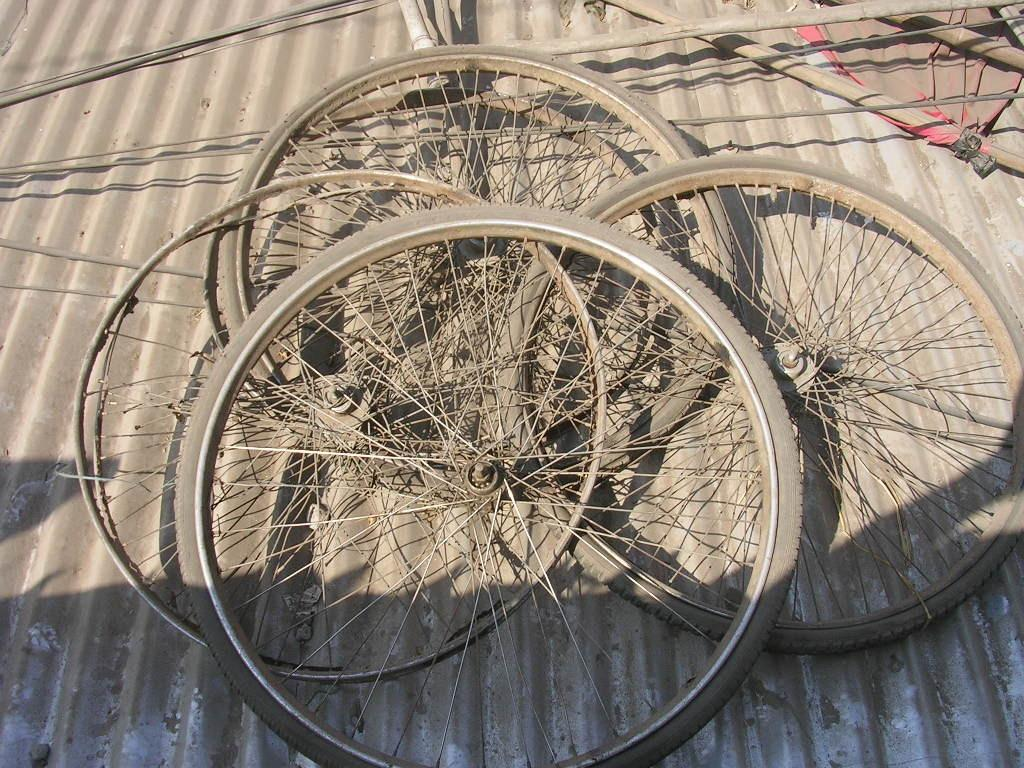What type of wheels are on the metal object in the image? There are bicycle wheels on the metal object. What else is attached to the metal object? There are sticks on the metal object. Can you describe the appearance of the metal object? The metal object has dust on it. What type of cloth is draped over the alley in the image? There is no alley or cloth present in the image; the image features a metal object with bicycle wheels and sticks, and dust on it. 